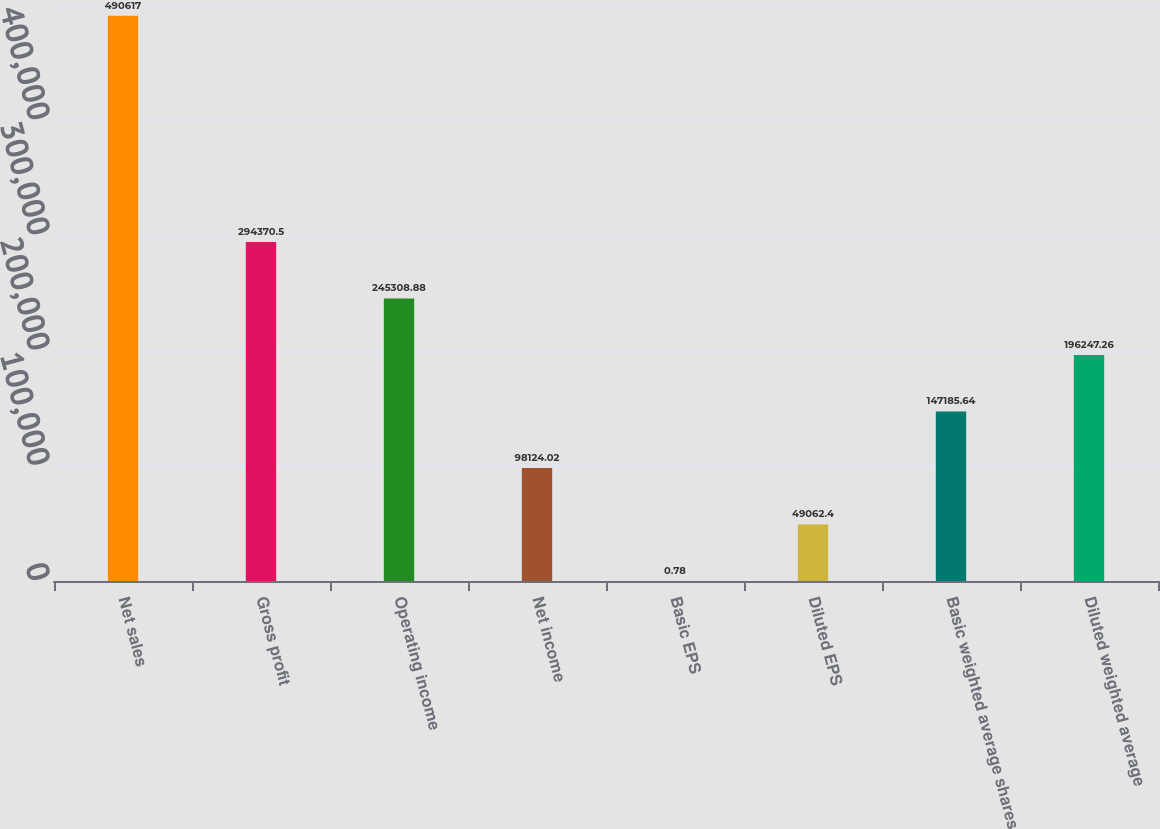Convert chart to OTSL. <chart><loc_0><loc_0><loc_500><loc_500><bar_chart><fcel>Net sales<fcel>Gross profit<fcel>Operating income<fcel>Net income<fcel>Basic EPS<fcel>Diluted EPS<fcel>Basic weighted average shares<fcel>Diluted weighted average<nl><fcel>490617<fcel>294370<fcel>245309<fcel>98124<fcel>0.78<fcel>49062.4<fcel>147186<fcel>196247<nl></chart> 